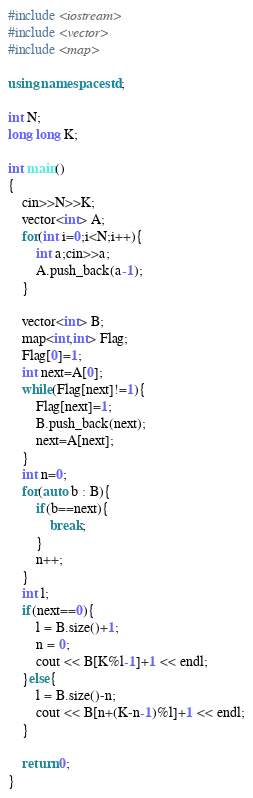<code> <loc_0><loc_0><loc_500><loc_500><_C++_>#include <iostream>
#include <vector>
#include <map>

using namespace std;

int N;
long long K;

int main()
{
    cin>>N>>K;
    vector<int> A;
    for(int i=0;i<N;i++){
        int a;cin>>a;
        A.push_back(a-1);
    }
    
    vector<int> B;
    map<int,int> Flag;
    Flag[0]=1;
    int next=A[0];
    while(Flag[next]!=1){
        Flag[next]=1;
        B.push_back(next);
        next=A[next];
    }
    int n=0;
    for(auto b : B){
        if(b==next){
            break;
        }
        n++;
    }
    int l;
    if(next==0){
        l = B.size()+1;
        n = 0;
        cout << B[K%l-1]+1 << endl;
    }else{
        l = B.size()-n;
        cout << B[n+(K-n-1)%l]+1 << endl;
    }

    return 0;
}</code> 